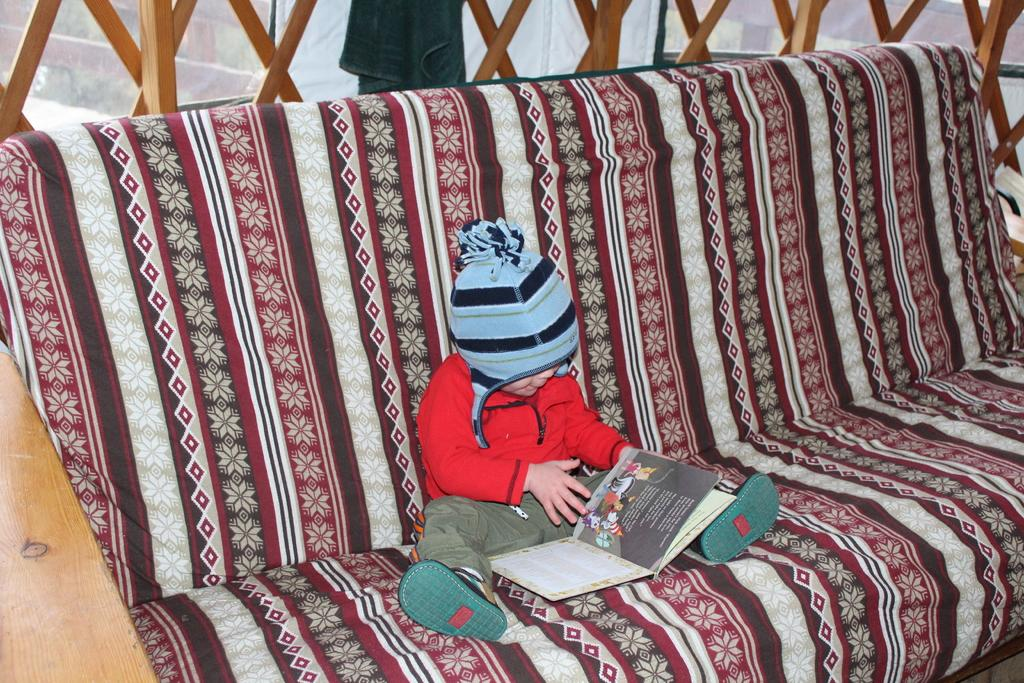What piece of furniture is in the image? There is a couch in the image. Who is sitting on the couch? A kid is sitting on the couch. What is the kid holding? The kid is holding a book. What can be seen at the top of the image? There are grills at the top of the image. How does the kid attack the grills in the image? The kid is not attacking the grills in the image; they are simply sitting on the couch and holding a book. 